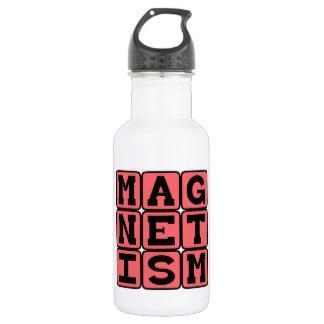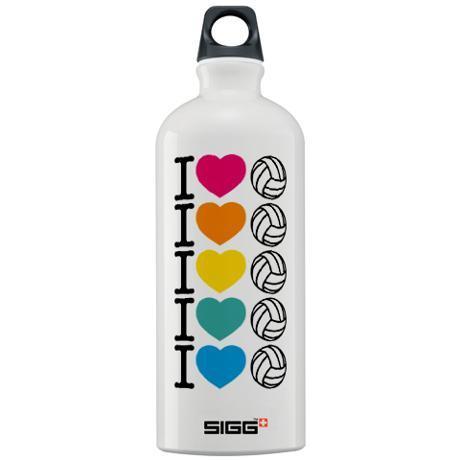The first image is the image on the left, the second image is the image on the right. Assess this claim about the two images: "One bottle has a round hole in the cap, and another bottle has an irregularly shaped hole in the cap.". Correct or not? Answer yes or no. Yes. The first image is the image on the left, the second image is the image on the right. Assess this claim about the two images: "A water bottle is decorated with three rows of letters on squares that spell out a word.". Correct or not? Answer yes or no. Yes. 